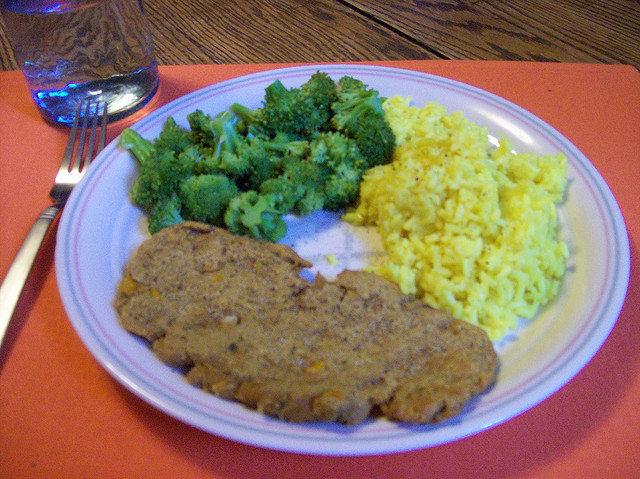What cooking techniques might have been used to prepare these foods? The broccoli may have been steamed or boiled to retain its bright green color and nutrients. The yellow rice could have been simmered in a seasoned broth to infuse it with flavors such as turmeric or saffron. The meatloaf is typically mixed with seasonings and other ingredients like breadcrumbs and eggs, then baked in the oven until thoroughly cooked. 